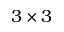Convert formula to latex. <formula><loc_0><loc_0><loc_500><loc_500>3 \times 3</formula> 